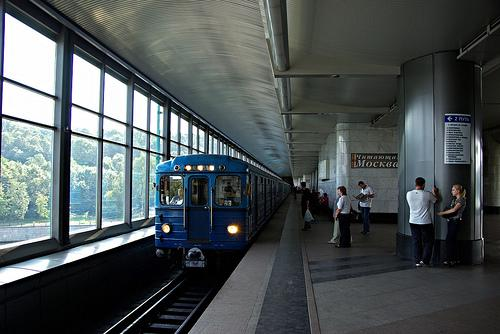Question: how many people are touching the column on the right hand side of the photo?
Choices:
A. Two.
B. Three.
C. Four.
D. Five.
Answer with the letter. Answer: A Question: what is providing the light that is coming through the windows?
Choices:
A. Street light.
B. Police car blue light.
C. Sun.
D. Porch light.
Answer with the letter. Answer: C Question: how many headlights does the train have on?
Choices:
A. Eight.
B. Six.
C. Seven.
D. Five.
Answer with the letter. Answer: D 